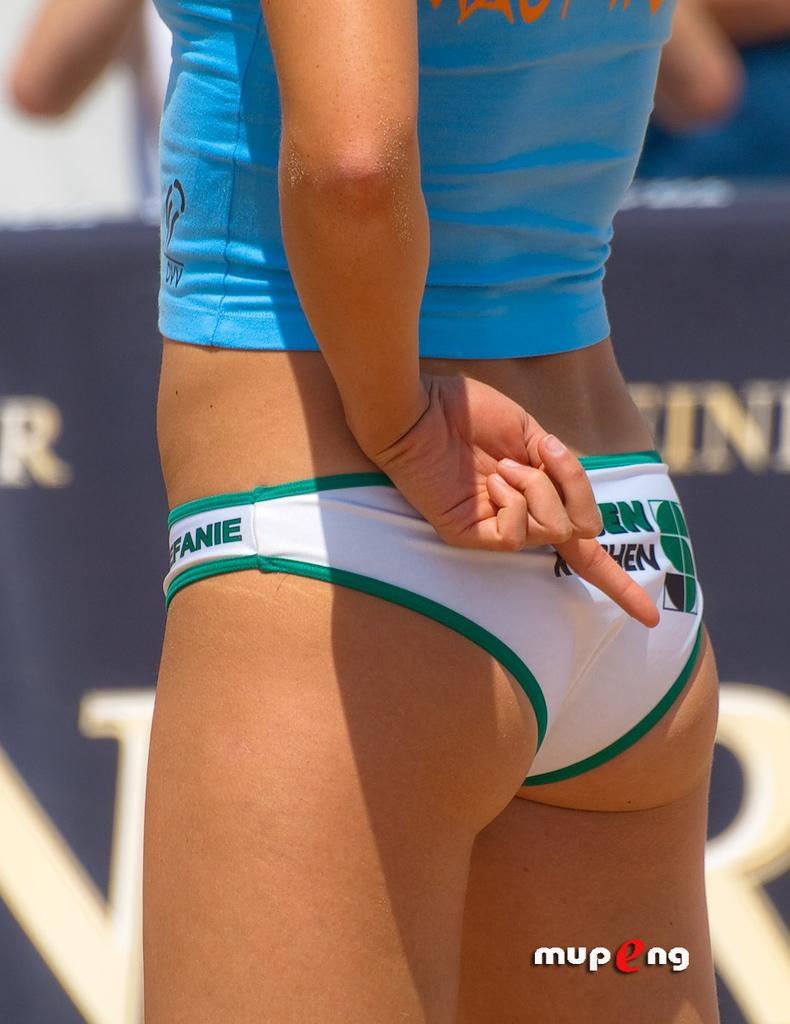<image>
Provide a brief description of the given image. A woman in a bathing suit with the partial word fanie on them. 